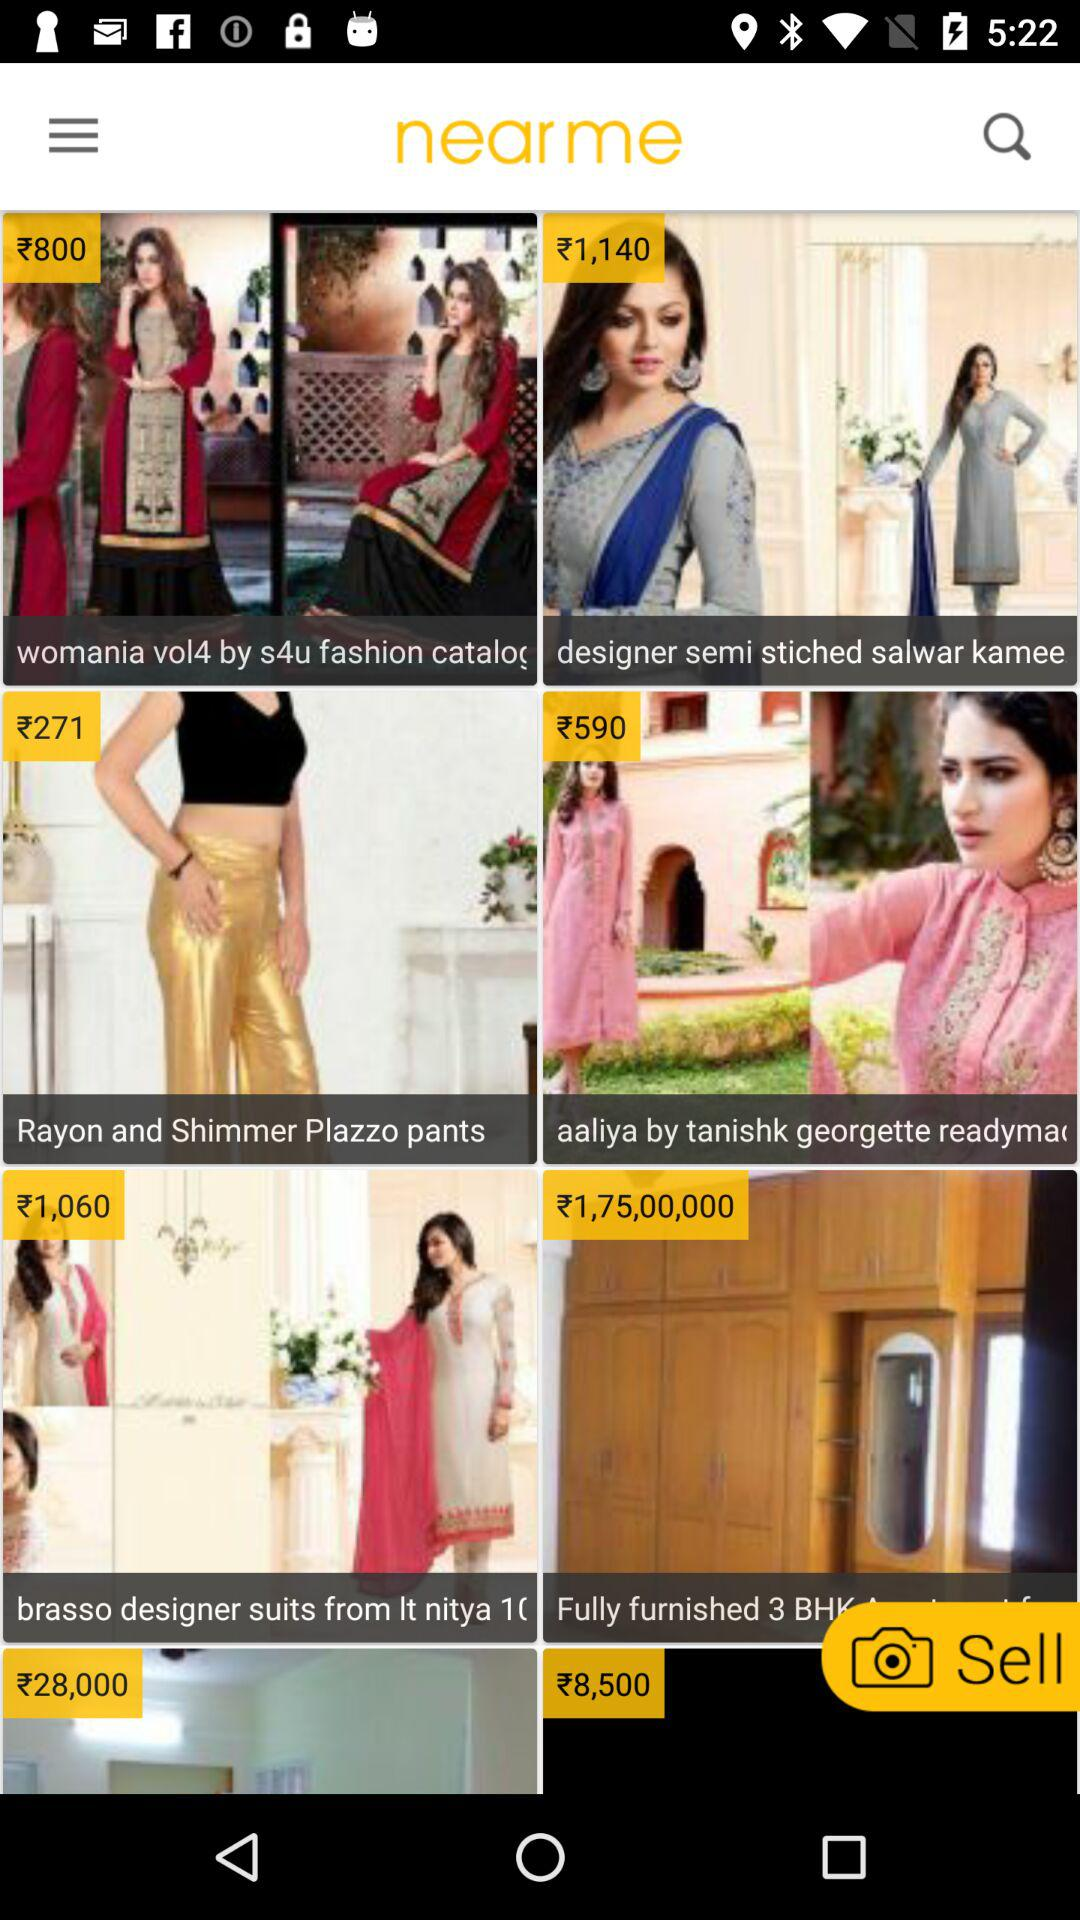What is the price of the "Rayon and Shimmer Plazzo pants"? The price of the "Rayon and Shimmer Plazzo pants" is ₹271. 